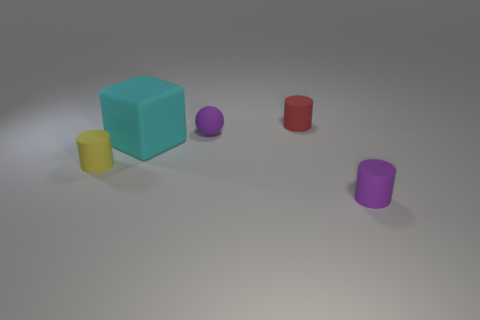Are there any yellow metallic objects that have the same shape as the cyan object?
Give a very brief answer. No. There is a tiny matte object that is both right of the purple rubber sphere and in front of the tiny red thing; what shape is it?
Give a very brief answer. Cylinder. Is the large block made of the same material as the tiny purple thing that is to the left of the tiny purple cylinder?
Ensure brevity in your answer.  Yes. There is a tiny purple matte ball; are there any cubes on the right side of it?
Your response must be concise. No. How many objects are tiny things or matte objects on the left side of the red cylinder?
Ensure brevity in your answer.  5. The small cylinder to the left of the purple object that is behind the large object is what color?
Give a very brief answer. Yellow. What number of other objects are the same material as the cyan thing?
Your answer should be very brief. 4. What number of matte objects are either small purple spheres or cylinders?
Your answer should be very brief. 4. How many objects are large gray cylinders or small things?
Make the answer very short. 4. What shape is the small red object that is the same material as the sphere?
Ensure brevity in your answer.  Cylinder. 